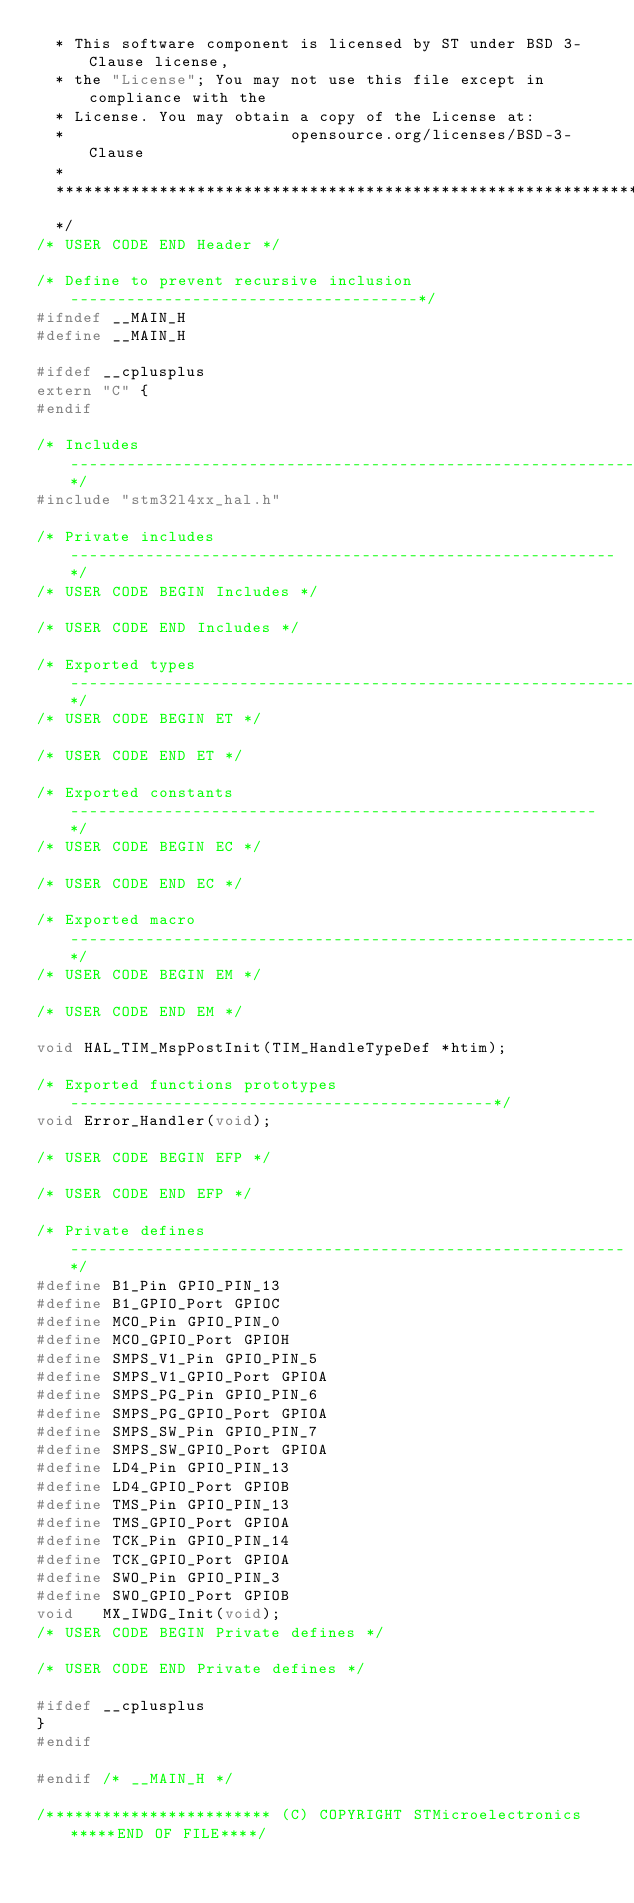<code> <loc_0><loc_0><loc_500><loc_500><_C_>  * This software component is licensed by ST under BSD 3-Clause license,
  * the "License"; You may not use this file except in compliance with the
  * License. You may obtain a copy of the License at:
  *                        opensource.org/licenses/BSD-3-Clause
  *
  ******************************************************************************
  */
/* USER CODE END Header */

/* Define to prevent recursive inclusion -------------------------------------*/
#ifndef __MAIN_H
#define __MAIN_H

#ifdef __cplusplus
extern "C" {
#endif

/* Includes ------------------------------------------------------------------*/
#include "stm32l4xx_hal.h"

/* Private includes ----------------------------------------------------------*/
/* USER CODE BEGIN Includes */

/* USER CODE END Includes */

/* Exported types ------------------------------------------------------------*/
/* USER CODE BEGIN ET */

/* USER CODE END ET */

/* Exported constants --------------------------------------------------------*/
/* USER CODE BEGIN EC */

/* USER CODE END EC */

/* Exported macro ------------------------------------------------------------*/
/* USER CODE BEGIN EM */

/* USER CODE END EM */

void HAL_TIM_MspPostInit(TIM_HandleTypeDef *htim);

/* Exported functions prototypes ---------------------------------------------*/
void Error_Handler(void);

/* USER CODE BEGIN EFP */

/* USER CODE END EFP */

/* Private defines -----------------------------------------------------------*/
#define B1_Pin GPIO_PIN_13
#define B1_GPIO_Port GPIOC
#define MCO_Pin GPIO_PIN_0
#define MCO_GPIO_Port GPIOH
#define SMPS_V1_Pin GPIO_PIN_5
#define SMPS_V1_GPIO_Port GPIOA
#define SMPS_PG_Pin GPIO_PIN_6
#define SMPS_PG_GPIO_Port GPIOA
#define SMPS_SW_Pin GPIO_PIN_7
#define SMPS_SW_GPIO_Port GPIOA
#define LD4_Pin GPIO_PIN_13
#define LD4_GPIO_Port GPIOB
#define TMS_Pin GPIO_PIN_13
#define TMS_GPIO_Port GPIOA
#define TCK_Pin GPIO_PIN_14
#define TCK_GPIO_Port GPIOA
#define SWO_Pin GPIO_PIN_3
#define SWO_GPIO_Port GPIOB
void   MX_IWDG_Init(void);
/* USER CODE BEGIN Private defines */

/* USER CODE END Private defines */

#ifdef __cplusplus
}
#endif

#endif /* __MAIN_H */

/************************ (C) COPYRIGHT STMicroelectronics *****END OF FILE****/
</code> 